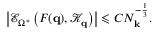<formula> <loc_0><loc_0><loc_500><loc_500>\left | \mathcal { E } _ { \Omega ^ { * } } \left ( F ( q ) , \mathcal { K } _ { q } \right ) \right | \leqslant C N _ { k } ^ { - \frac { 1 } { 3 } } .</formula> 